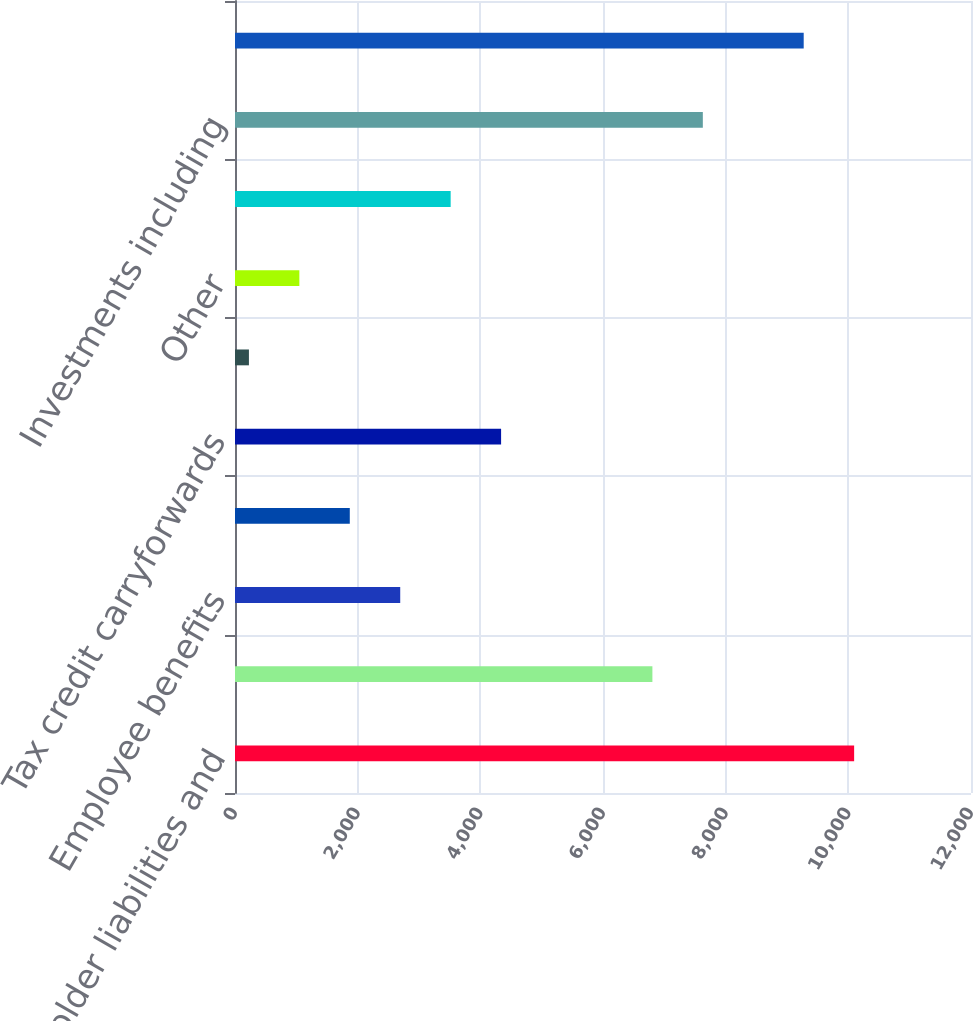Convert chart to OTSL. <chart><loc_0><loc_0><loc_500><loc_500><bar_chart><fcel>Policyholder liabilities and<fcel>Net operating loss<fcel>Employee benefits<fcel>Capital loss carryforwards<fcel>Tax credit carryforwards<fcel>Litigation-related and<fcel>Other<fcel>Less Valuation allowance<fcel>Investments including<fcel>Intangibles<nl><fcel>10094.6<fcel>6805.4<fcel>2693.9<fcel>1871.6<fcel>4338.5<fcel>227<fcel>1049.3<fcel>3516.2<fcel>7627.7<fcel>9272.3<nl></chart> 